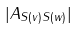<formula> <loc_0><loc_0><loc_500><loc_500>| A _ { S ( v ) S ( w ) } |</formula> 